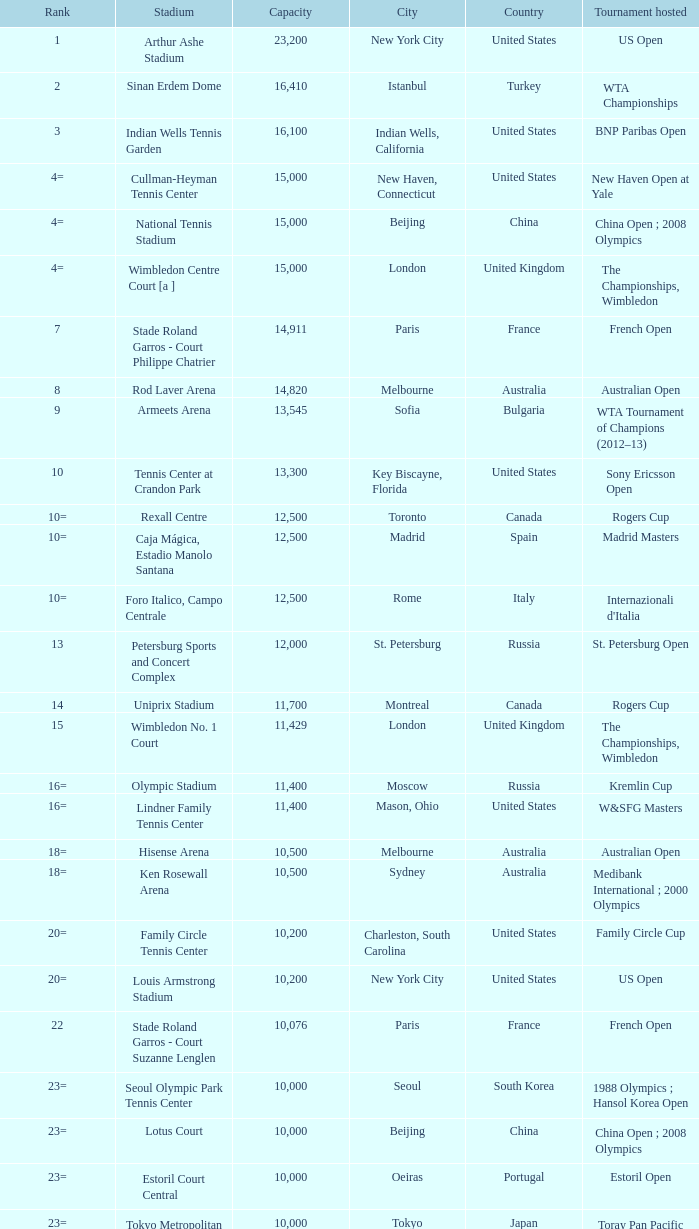What is the average capacity that has rod laver arena as the stadium? 14820.0. 